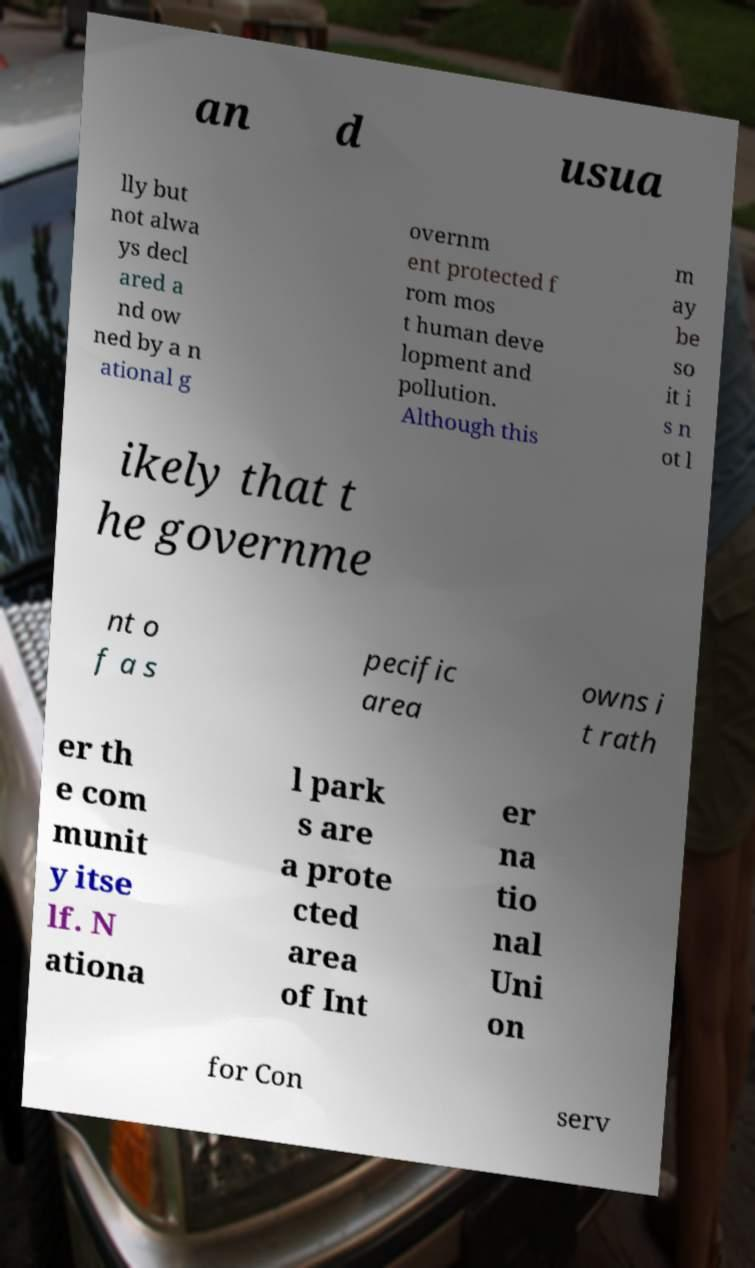Could you assist in decoding the text presented in this image and type it out clearly? an d usua lly but not alwa ys decl ared a nd ow ned by a n ational g overnm ent protected f rom mos t human deve lopment and pollution. Although this m ay be so it i s n ot l ikely that t he governme nt o f a s pecific area owns i t rath er th e com munit y itse lf. N ationa l park s are a prote cted area of Int er na tio nal Uni on for Con serv 